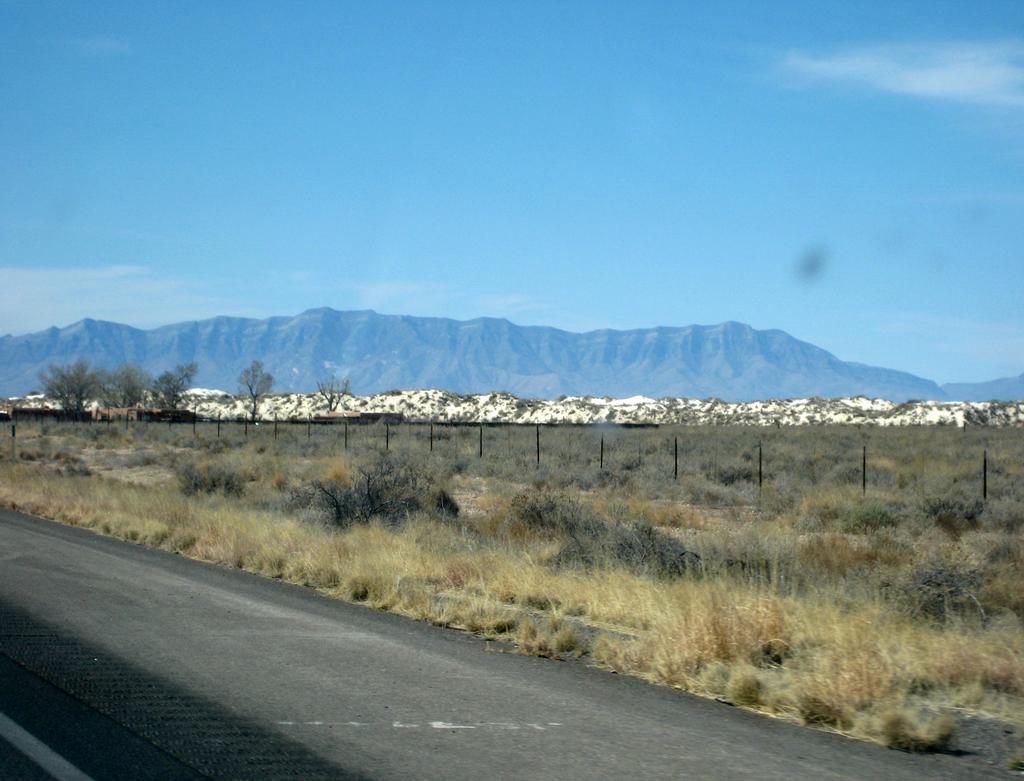Describe this image in one or two sentences. In this image I can see dry grass,fencing,trees and mountains. The sky is in white and blue color. 